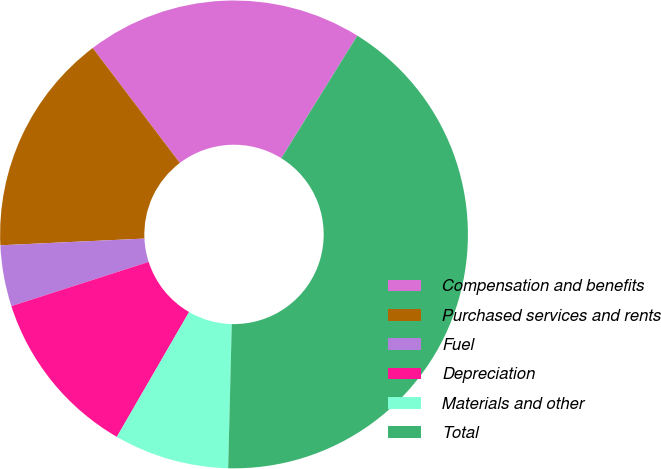<chart> <loc_0><loc_0><loc_500><loc_500><pie_chart><fcel>Compensation and benefits<fcel>Purchased services and rents<fcel>Fuel<fcel>Depreciation<fcel>Materials and other<fcel>Total<nl><fcel>19.16%<fcel>15.42%<fcel>4.22%<fcel>11.69%<fcel>7.95%<fcel>41.56%<nl></chart> 